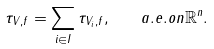<formula> <loc_0><loc_0><loc_500><loc_500>\tau _ { V , f } = \sum _ { i \in I } \tau _ { V _ { i } , f } , \quad a . e . o n \mathbb { R } ^ { n } .</formula> 